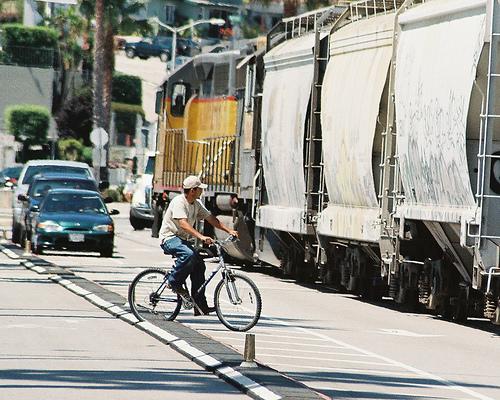What kind of vehicle is passing?
Give a very brief answer. Train. What kind of pants is the biker wearing?
Quick response, please. Jeans. How many cars are there in the photo?
Write a very short answer. 3. 